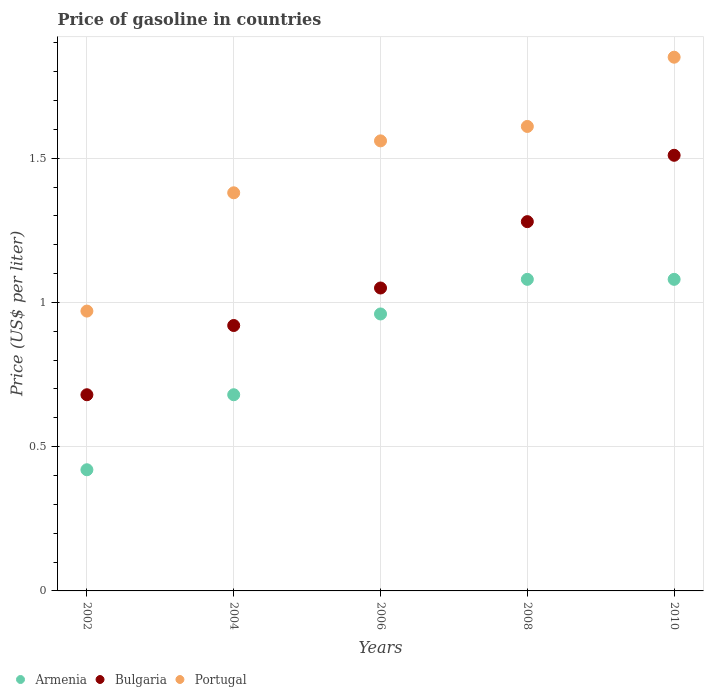What is the price of gasoline in Armenia in 2008?
Your answer should be compact. 1.08. Across all years, what is the maximum price of gasoline in Portugal?
Provide a short and direct response. 1.85. Across all years, what is the minimum price of gasoline in Armenia?
Keep it short and to the point. 0.42. In which year was the price of gasoline in Bulgaria maximum?
Ensure brevity in your answer.  2010. What is the total price of gasoline in Armenia in the graph?
Your answer should be very brief. 4.22. What is the difference between the price of gasoline in Portugal in 2004 and that in 2010?
Your answer should be very brief. -0.47. What is the difference between the price of gasoline in Portugal in 2006 and the price of gasoline in Bulgaria in 2002?
Give a very brief answer. 0.88. What is the average price of gasoline in Armenia per year?
Your answer should be very brief. 0.84. In the year 2006, what is the difference between the price of gasoline in Armenia and price of gasoline in Portugal?
Your answer should be compact. -0.6. In how many years, is the price of gasoline in Armenia greater than 0.9 US$?
Keep it short and to the point. 3. What is the ratio of the price of gasoline in Bulgaria in 2002 to that in 2006?
Ensure brevity in your answer.  0.65. Is the price of gasoline in Bulgaria in 2004 less than that in 2010?
Give a very brief answer. Yes. What is the difference between the highest and the second highest price of gasoline in Bulgaria?
Ensure brevity in your answer.  0.23. What is the difference between the highest and the lowest price of gasoline in Bulgaria?
Your answer should be compact. 0.83. Is the sum of the price of gasoline in Portugal in 2006 and 2010 greater than the maximum price of gasoline in Armenia across all years?
Provide a succinct answer. Yes. Is the price of gasoline in Armenia strictly greater than the price of gasoline in Portugal over the years?
Keep it short and to the point. No. Is the price of gasoline in Bulgaria strictly less than the price of gasoline in Portugal over the years?
Keep it short and to the point. Yes. How many dotlines are there?
Ensure brevity in your answer.  3. Are the values on the major ticks of Y-axis written in scientific E-notation?
Offer a very short reply. No. Does the graph contain any zero values?
Your response must be concise. No. Where does the legend appear in the graph?
Ensure brevity in your answer.  Bottom left. How are the legend labels stacked?
Ensure brevity in your answer.  Horizontal. What is the title of the graph?
Your answer should be very brief. Price of gasoline in countries. Does "Jamaica" appear as one of the legend labels in the graph?
Keep it short and to the point. No. What is the label or title of the X-axis?
Offer a very short reply. Years. What is the label or title of the Y-axis?
Your answer should be very brief. Price (US$ per liter). What is the Price (US$ per liter) of Armenia in 2002?
Give a very brief answer. 0.42. What is the Price (US$ per liter) of Bulgaria in 2002?
Ensure brevity in your answer.  0.68. What is the Price (US$ per liter) of Portugal in 2002?
Your answer should be compact. 0.97. What is the Price (US$ per liter) in Armenia in 2004?
Ensure brevity in your answer.  0.68. What is the Price (US$ per liter) in Portugal in 2004?
Make the answer very short. 1.38. What is the Price (US$ per liter) in Armenia in 2006?
Make the answer very short. 0.96. What is the Price (US$ per liter) in Bulgaria in 2006?
Provide a short and direct response. 1.05. What is the Price (US$ per liter) in Portugal in 2006?
Offer a very short reply. 1.56. What is the Price (US$ per liter) in Armenia in 2008?
Provide a short and direct response. 1.08. What is the Price (US$ per liter) of Bulgaria in 2008?
Your response must be concise. 1.28. What is the Price (US$ per liter) in Portugal in 2008?
Offer a very short reply. 1.61. What is the Price (US$ per liter) of Armenia in 2010?
Your answer should be very brief. 1.08. What is the Price (US$ per liter) in Bulgaria in 2010?
Your answer should be very brief. 1.51. What is the Price (US$ per liter) of Portugal in 2010?
Give a very brief answer. 1.85. Across all years, what is the maximum Price (US$ per liter) in Armenia?
Give a very brief answer. 1.08. Across all years, what is the maximum Price (US$ per liter) in Bulgaria?
Your answer should be very brief. 1.51. Across all years, what is the maximum Price (US$ per liter) of Portugal?
Ensure brevity in your answer.  1.85. Across all years, what is the minimum Price (US$ per liter) of Armenia?
Offer a terse response. 0.42. Across all years, what is the minimum Price (US$ per liter) of Bulgaria?
Keep it short and to the point. 0.68. Across all years, what is the minimum Price (US$ per liter) in Portugal?
Offer a terse response. 0.97. What is the total Price (US$ per liter) in Armenia in the graph?
Your answer should be very brief. 4.22. What is the total Price (US$ per liter) in Bulgaria in the graph?
Provide a succinct answer. 5.44. What is the total Price (US$ per liter) of Portugal in the graph?
Your answer should be compact. 7.37. What is the difference between the Price (US$ per liter) in Armenia in 2002 and that in 2004?
Provide a succinct answer. -0.26. What is the difference between the Price (US$ per liter) of Bulgaria in 2002 and that in 2004?
Offer a terse response. -0.24. What is the difference between the Price (US$ per liter) of Portugal in 2002 and that in 2004?
Ensure brevity in your answer.  -0.41. What is the difference between the Price (US$ per liter) of Armenia in 2002 and that in 2006?
Give a very brief answer. -0.54. What is the difference between the Price (US$ per liter) in Bulgaria in 2002 and that in 2006?
Provide a succinct answer. -0.37. What is the difference between the Price (US$ per liter) in Portugal in 2002 and that in 2006?
Provide a succinct answer. -0.59. What is the difference between the Price (US$ per liter) of Armenia in 2002 and that in 2008?
Offer a very short reply. -0.66. What is the difference between the Price (US$ per liter) in Bulgaria in 2002 and that in 2008?
Ensure brevity in your answer.  -0.6. What is the difference between the Price (US$ per liter) in Portugal in 2002 and that in 2008?
Provide a short and direct response. -0.64. What is the difference between the Price (US$ per liter) in Armenia in 2002 and that in 2010?
Offer a very short reply. -0.66. What is the difference between the Price (US$ per liter) in Bulgaria in 2002 and that in 2010?
Make the answer very short. -0.83. What is the difference between the Price (US$ per liter) of Portugal in 2002 and that in 2010?
Offer a terse response. -0.88. What is the difference between the Price (US$ per liter) of Armenia in 2004 and that in 2006?
Provide a succinct answer. -0.28. What is the difference between the Price (US$ per liter) of Bulgaria in 2004 and that in 2006?
Your response must be concise. -0.13. What is the difference between the Price (US$ per liter) of Portugal in 2004 and that in 2006?
Give a very brief answer. -0.18. What is the difference between the Price (US$ per liter) in Armenia in 2004 and that in 2008?
Provide a short and direct response. -0.4. What is the difference between the Price (US$ per liter) in Bulgaria in 2004 and that in 2008?
Your answer should be compact. -0.36. What is the difference between the Price (US$ per liter) in Portugal in 2004 and that in 2008?
Your response must be concise. -0.23. What is the difference between the Price (US$ per liter) in Bulgaria in 2004 and that in 2010?
Ensure brevity in your answer.  -0.59. What is the difference between the Price (US$ per liter) of Portugal in 2004 and that in 2010?
Keep it short and to the point. -0.47. What is the difference between the Price (US$ per liter) of Armenia in 2006 and that in 2008?
Offer a terse response. -0.12. What is the difference between the Price (US$ per liter) in Bulgaria in 2006 and that in 2008?
Give a very brief answer. -0.23. What is the difference between the Price (US$ per liter) of Portugal in 2006 and that in 2008?
Ensure brevity in your answer.  -0.05. What is the difference between the Price (US$ per liter) of Armenia in 2006 and that in 2010?
Keep it short and to the point. -0.12. What is the difference between the Price (US$ per liter) in Bulgaria in 2006 and that in 2010?
Your response must be concise. -0.46. What is the difference between the Price (US$ per liter) of Portugal in 2006 and that in 2010?
Your answer should be compact. -0.29. What is the difference between the Price (US$ per liter) of Armenia in 2008 and that in 2010?
Provide a succinct answer. 0. What is the difference between the Price (US$ per liter) of Bulgaria in 2008 and that in 2010?
Your response must be concise. -0.23. What is the difference between the Price (US$ per liter) of Portugal in 2008 and that in 2010?
Offer a very short reply. -0.24. What is the difference between the Price (US$ per liter) of Armenia in 2002 and the Price (US$ per liter) of Bulgaria in 2004?
Make the answer very short. -0.5. What is the difference between the Price (US$ per liter) in Armenia in 2002 and the Price (US$ per liter) in Portugal in 2004?
Keep it short and to the point. -0.96. What is the difference between the Price (US$ per liter) in Bulgaria in 2002 and the Price (US$ per liter) in Portugal in 2004?
Offer a terse response. -0.7. What is the difference between the Price (US$ per liter) of Armenia in 2002 and the Price (US$ per liter) of Bulgaria in 2006?
Your answer should be compact. -0.63. What is the difference between the Price (US$ per liter) of Armenia in 2002 and the Price (US$ per liter) of Portugal in 2006?
Your answer should be compact. -1.14. What is the difference between the Price (US$ per liter) of Bulgaria in 2002 and the Price (US$ per liter) of Portugal in 2006?
Ensure brevity in your answer.  -0.88. What is the difference between the Price (US$ per liter) of Armenia in 2002 and the Price (US$ per liter) of Bulgaria in 2008?
Your answer should be very brief. -0.86. What is the difference between the Price (US$ per liter) of Armenia in 2002 and the Price (US$ per liter) of Portugal in 2008?
Your answer should be very brief. -1.19. What is the difference between the Price (US$ per liter) of Bulgaria in 2002 and the Price (US$ per liter) of Portugal in 2008?
Your answer should be compact. -0.93. What is the difference between the Price (US$ per liter) in Armenia in 2002 and the Price (US$ per liter) in Bulgaria in 2010?
Your response must be concise. -1.09. What is the difference between the Price (US$ per liter) in Armenia in 2002 and the Price (US$ per liter) in Portugal in 2010?
Your answer should be very brief. -1.43. What is the difference between the Price (US$ per liter) of Bulgaria in 2002 and the Price (US$ per liter) of Portugal in 2010?
Offer a very short reply. -1.17. What is the difference between the Price (US$ per liter) of Armenia in 2004 and the Price (US$ per liter) of Bulgaria in 2006?
Provide a succinct answer. -0.37. What is the difference between the Price (US$ per liter) of Armenia in 2004 and the Price (US$ per liter) of Portugal in 2006?
Offer a terse response. -0.88. What is the difference between the Price (US$ per liter) in Bulgaria in 2004 and the Price (US$ per liter) in Portugal in 2006?
Provide a succinct answer. -0.64. What is the difference between the Price (US$ per liter) in Armenia in 2004 and the Price (US$ per liter) in Portugal in 2008?
Provide a short and direct response. -0.93. What is the difference between the Price (US$ per liter) in Bulgaria in 2004 and the Price (US$ per liter) in Portugal in 2008?
Provide a succinct answer. -0.69. What is the difference between the Price (US$ per liter) in Armenia in 2004 and the Price (US$ per liter) in Bulgaria in 2010?
Offer a terse response. -0.83. What is the difference between the Price (US$ per liter) in Armenia in 2004 and the Price (US$ per liter) in Portugal in 2010?
Provide a short and direct response. -1.17. What is the difference between the Price (US$ per liter) of Bulgaria in 2004 and the Price (US$ per liter) of Portugal in 2010?
Your answer should be compact. -0.93. What is the difference between the Price (US$ per liter) of Armenia in 2006 and the Price (US$ per liter) of Bulgaria in 2008?
Give a very brief answer. -0.32. What is the difference between the Price (US$ per liter) in Armenia in 2006 and the Price (US$ per liter) in Portugal in 2008?
Provide a succinct answer. -0.65. What is the difference between the Price (US$ per liter) in Bulgaria in 2006 and the Price (US$ per liter) in Portugal in 2008?
Offer a terse response. -0.56. What is the difference between the Price (US$ per liter) in Armenia in 2006 and the Price (US$ per liter) in Bulgaria in 2010?
Keep it short and to the point. -0.55. What is the difference between the Price (US$ per liter) in Armenia in 2006 and the Price (US$ per liter) in Portugal in 2010?
Offer a terse response. -0.89. What is the difference between the Price (US$ per liter) of Bulgaria in 2006 and the Price (US$ per liter) of Portugal in 2010?
Your answer should be very brief. -0.8. What is the difference between the Price (US$ per liter) of Armenia in 2008 and the Price (US$ per liter) of Bulgaria in 2010?
Offer a very short reply. -0.43. What is the difference between the Price (US$ per liter) in Armenia in 2008 and the Price (US$ per liter) in Portugal in 2010?
Your answer should be compact. -0.77. What is the difference between the Price (US$ per liter) in Bulgaria in 2008 and the Price (US$ per liter) in Portugal in 2010?
Give a very brief answer. -0.57. What is the average Price (US$ per liter) of Armenia per year?
Give a very brief answer. 0.84. What is the average Price (US$ per liter) in Bulgaria per year?
Ensure brevity in your answer.  1.09. What is the average Price (US$ per liter) in Portugal per year?
Provide a short and direct response. 1.47. In the year 2002, what is the difference between the Price (US$ per liter) of Armenia and Price (US$ per liter) of Bulgaria?
Offer a very short reply. -0.26. In the year 2002, what is the difference between the Price (US$ per liter) in Armenia and Price (US$ per liter) in Portugal?
Ensure brevity in your answer.  -0.55. In the year 2002, what is the difference between the Price (US$ per liter) in Bulgaria and Price (US$ per liter) in Portugal?
Provide a short and direct response. -0.29. In the year 2004, what is the difference between the Price (US$ per liter) of Armenia and Price (US$ per liter) of Bulgaria?
Provide a short and direct response. -0.24. In the year 2004, what is the difference between the Price (US$ per liter) of Bulgaria and Price (US$ per liter) of Portugal?
Provide a succinct answer. -0.46. In the year 2006, what is the difference between the Price (US$ per liter) in Armenia and Price (US$ per liter) in Bulgaria?
Your response must be concise. -0.09. In the year 2006, what is the difference between the Price (US$ per liter) of Armenia and Price (US$ per liter) of Portugal?
Provide a short and direct response. -0.6. In the year 2006, what is the difference between the Price (US$ per liter) in Bulgaria and Price (US$ per liter) in Portugal?
Keep it short and to the point. -0.51. In the year 2008, what is the difference between the Price (US$ per liter) of Armenia and Price (US$ per liter) of Bulgaria?
Provide a succinct answer. -0.2. In the year 2008, what is the difference between the Price (US$ per liter) of Armenia and Price (US$ per liter) of Portugal?
Offer a terse response. -0.53. In the year 2008, what is the difference between the Price (US$ per liter) of Bulgaria and Price (US$ per liter) of Portugal?
Offer a very short reply. -0.33. In the year 2010, what is the difference between the Price (US$ per liter) in Armenia and Price (US$ per liter) in Bulgaria?
Your answer should be very brief. -0.43. In the year 2010, what is the difference between the Price (US$ per liter) of Armenia and Price (US$ per liter) of Portugal?
Provide a succinct answer. -0.77. In the year 2010, what is the difference between the Price (US$ per liter) in Bulgaria and Price (US$ per liter) in Portugal?
Provide a short and direct response. -0.34. What is the ratio of the Price (US$ per liter) of Armenia in 2002 to that in 2004?
Provide a short and direct response. 0.62. What is the ratio of the Price (US$ per liter) of Bulgaria in 2002 to that in 2004?
Offer a very short reply. 0.74. What is the ratio of the Price (US$ per liter) of Portugal in 2002 to that in 2004?
Give a very brief answer. 0.7. What is the ratio of the Price (US$ per liter) in Armenia in 2002 to that in 2006?
Keep it short and to the point. 0.44. What is the ratio of the Price (US$ per liter) of Bulgaria in 2002 to that in 2006?
Provide a succinct answer. 0.65. What is the ratio of the Price (US$ per liter) of Portugal in 2002 to that in 2006?
Your answer should be very brief. 0.62. What is the ratio of the Price (US$ per liter) in Armenia in 2002 to that in 2008?
Your response must be concise. 0.39. What is the ratio of the Price (US$ per liter) of Bulgaria in 2002 to that in 2008?
Ensure brevity in your answer.  0.53. What is the ratio of the Price (US$ per liter) in Portugal in 2002 to that in 2008?
Ensure brevity in your answer.  0.6. What is the ratio of the Price (US$ per liter) in Armenia in 2002 to that in 2010?
Give a very brief answer. 0.39. What is the ratio of the Price (US$ per liter) in Bulgaria in 2002 to that in 2010?
Offer a terse response. 0.45. What is the ratio of the Price (US$ per liter) in Portugal in 2002 to that in 2010?
Offer a terse response. 0.52. What is the ratio of the Price (US$ per liter) in Armenia in 2004 to that in 2006?
Keep it short and to the point. 0.71. What is the ratio of the Price (US$ per liter) in Bulgaria in 2004 to that in 2006?
Ensure brevity in your answer.  0.88. What is the ratio of the Price (US$ per liter) in Portugal in 2004 to that in 2006?
Keep it short and to the point. 0.88. What is the ratio of the Price (US$ per liter) in Armenia in 2004 to that in 2008?
Offer a terse response. 0.63. What is the ratio of the Price (US$ per liter) in Bulgaria in 2004 to that in 2008?
Make the answer very short. 0.72. What is the ratio of the Price (US$ per liter) in Armenia in 2004 to that in 2010?
Offer a terse response. 0.63. What is the ratio of the Price (US$ per liter) of Bulgaria in 2004 to that in 2010?
Provide a succinct answer. 0.61. What is the ratio of the Price (US$ per liter) in Portugal in 2004 to that in 2010?
Offer a terse response. 0.75. What is the ratio of the Price (US$ per liter) of Armenia in 2006 to that in 2008?
Provide a short and direct response. 0.89. What is the ratio of the Price (US$ per liter) of Bulgaria in 2006 to that in 2008?
Offer a very short reply. 0.82. What is the ratio of the Price (US$ per liter) in Portugal in 2006 to that in 2008?
Your response must be concise. 0.97. What is the ratio of the Price (US$ per liter) of Bulgaria in 2006 to that in 2010?
Provide a succinct answer. 0.7. What is the ratio of the Price (US$ per liter) in Portugal in 2006 to that in 2010?
Make the answer very short. 0.84. What is the ratio of the Price (US$ per liter) of Armenia in 2008 to that in 2010?
Your answer should be very brief. 1. What is the ratio of the Price (US$ per liter) of Bulgaria in 2008 to that in 2010?
Offer a terse response. 0.85. What is the ratio of the Price (US$ per liter) of Portugal in 2008 to that in 2010?
Your answer should be very brief. 0.87. What is the difference between the highest and the second highest Price (US$ per liter) of Armenia?
Your answer should be very brief. 0. What is the difference between the highest and the second highest Price (US$ per liter) of Bulgaria?
Provide a short and direct response. 0.23. What is the difference between the highest and the second highest Price (US$ per liter) in Portugal?
Make the answer very short. 0.24. What is the difference between the highest and the lowest Price (US$ per liter) of Armenia?
Your answer should be compact. 0.66. What is the difference between the highest and the lowest Price (US$ per liter) in Bulgaria?
Ensure brevity in your answer.  0.83. What is the difference between the highest and the lowest Price (US$ per liter) of Portugal?
Make the answer very short. 0.88. 